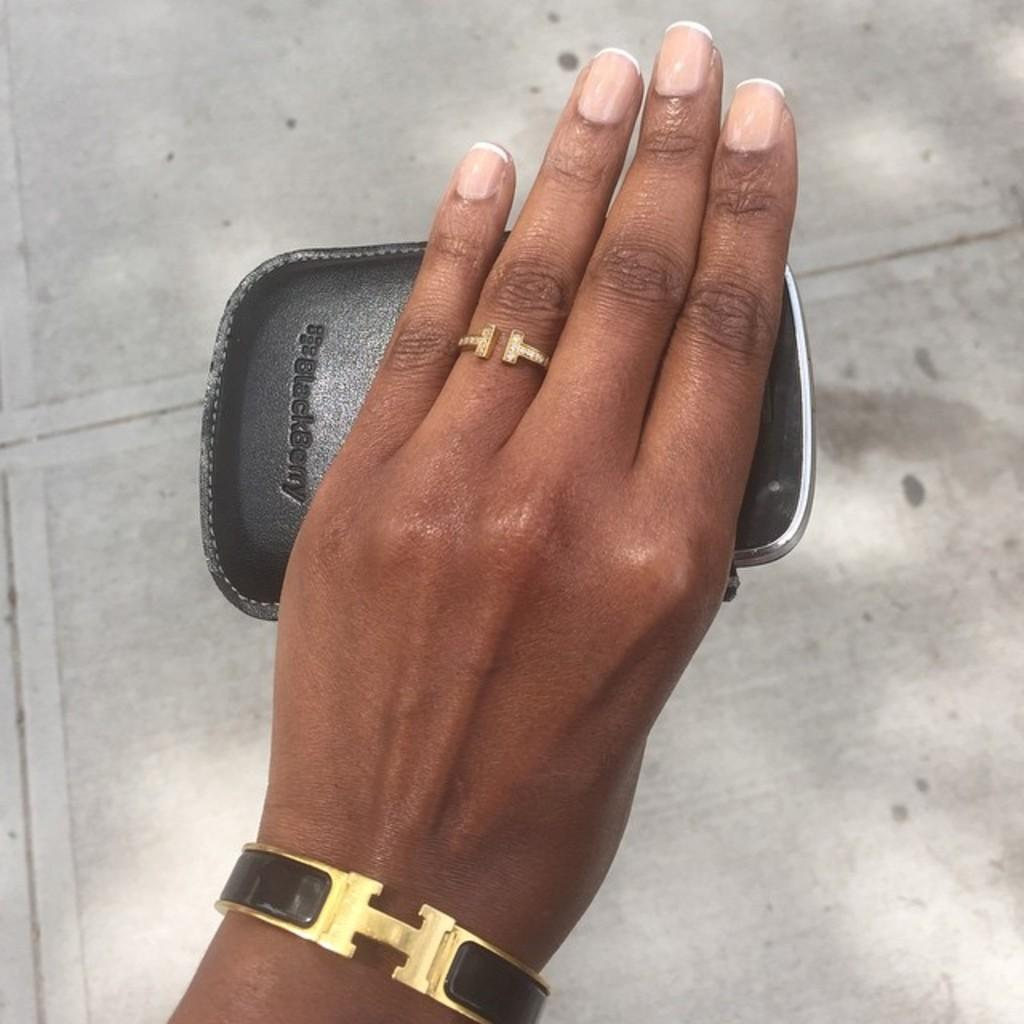Provide a one-sentence caption for the provided image. A womans hand holding a case with the word blackberry printed on it. 